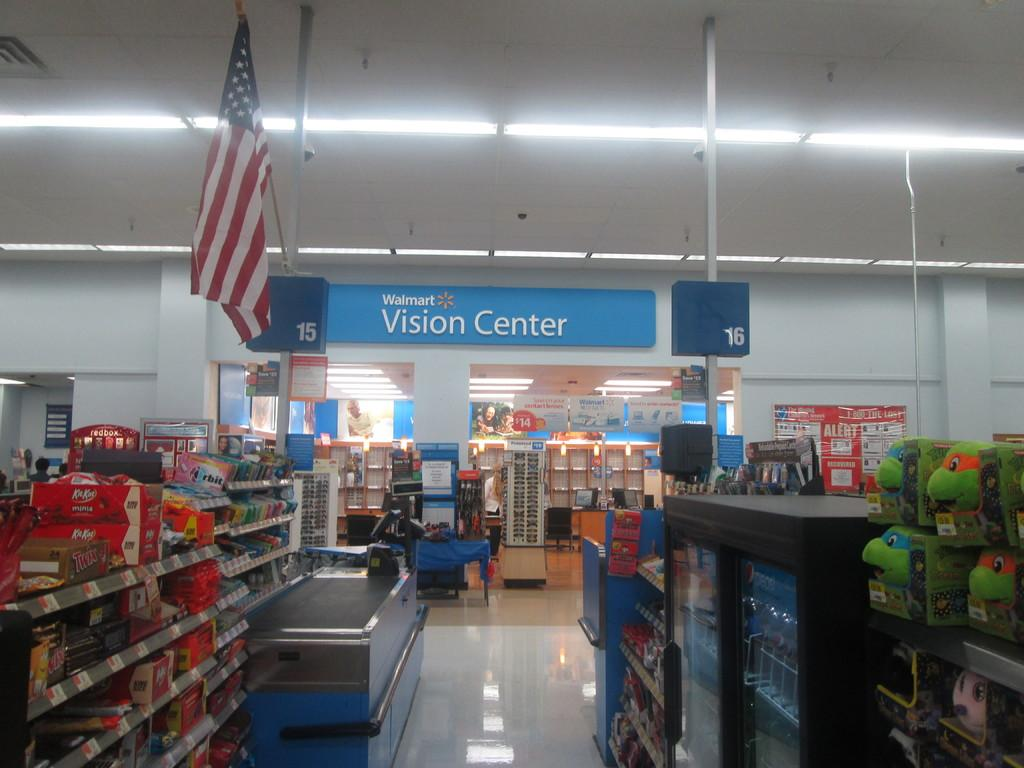<image>
Share a concise interpretation of the image provided. Walmart Vision Center is easily recognizable by the US flag that hangs above its entrance. 